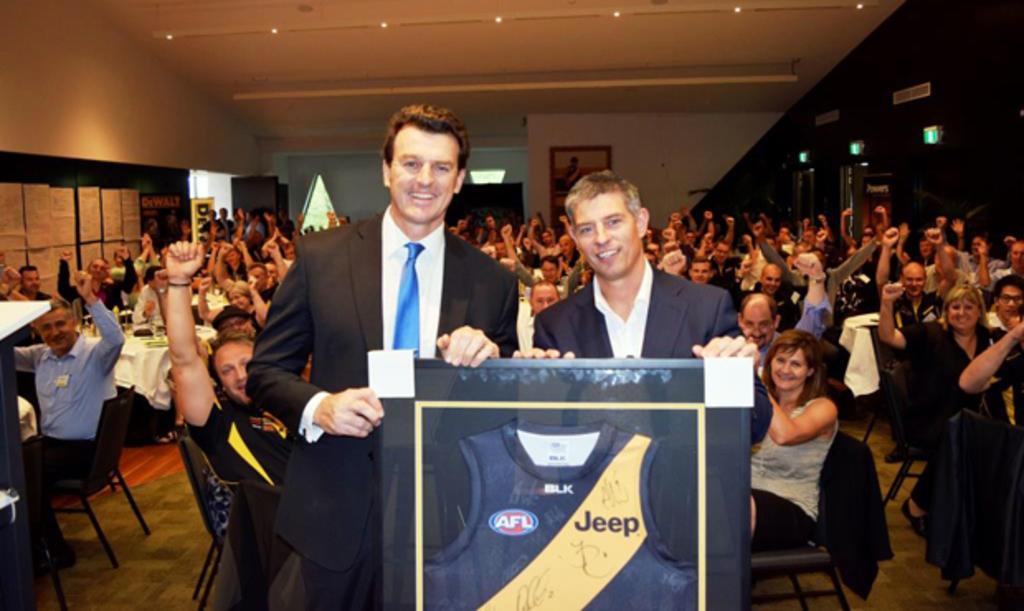How would you summarize this image in a sentence or two? In this image we can see few people sitting in the background, two people are standing in front of them are holding a picture frame, on the left side there is a board with posts attached to it, there are few lights to the ceiling, on the right side there are there are sign board and boards with text attached to the wall. 